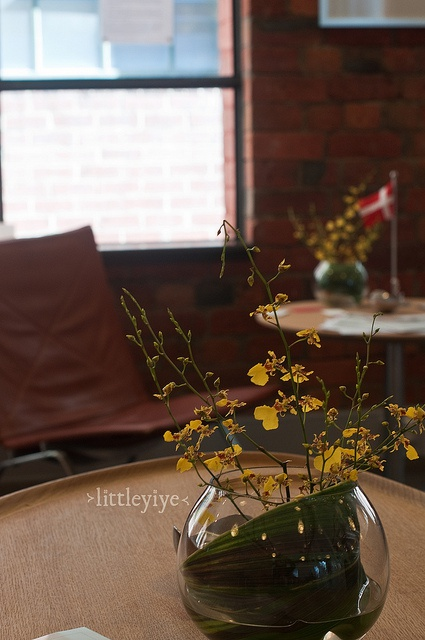Describe the objects in this image and their specific colors. I can see potted plant in lightblue, black, maroon, and gray tones, vase in lightblue, black, maroon, and gray tones, chair in lightblue, maroon, and brown tones, potted plant in lightblue, black, maroon, olive, and gray tones, and vase in lightblue, black, and gray tones in this image. 